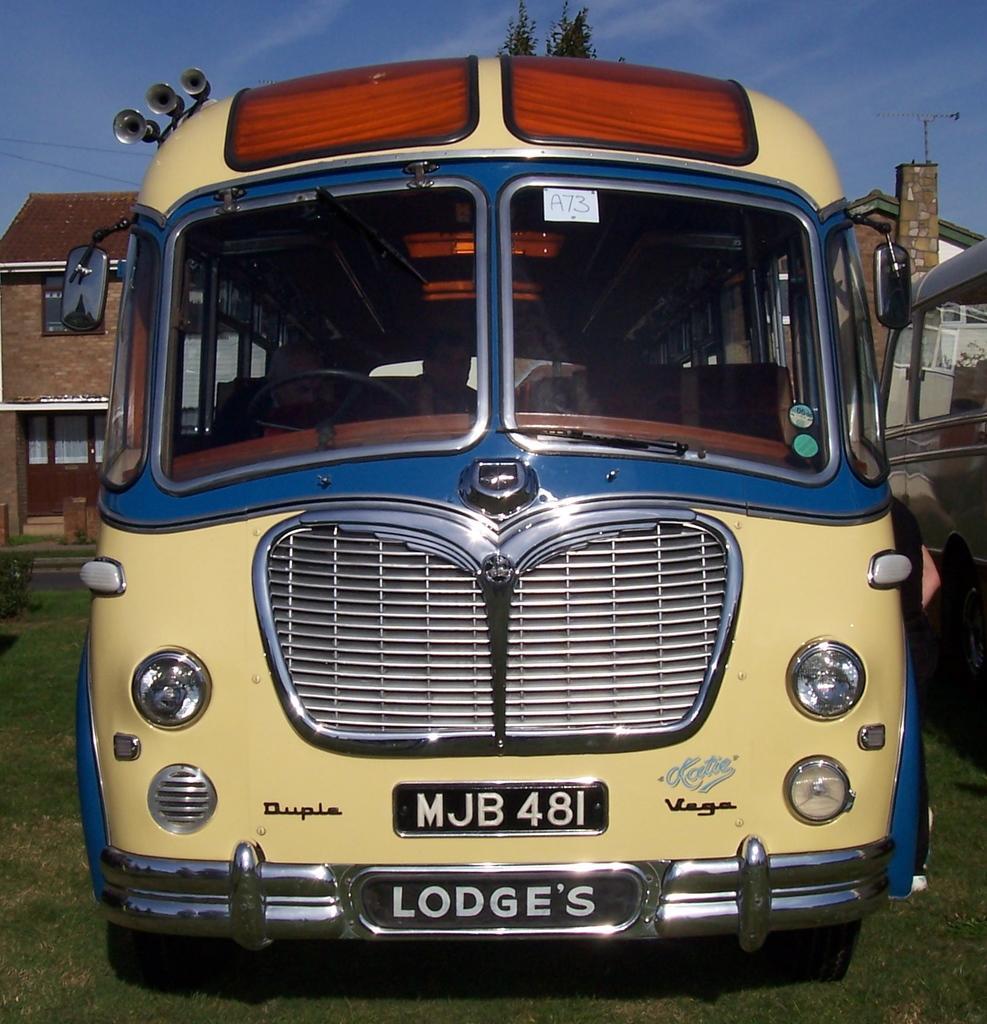Describe this image in one or two sentences. There is a bus with a number plate and windows. In the background there is a building, sky and tree. 